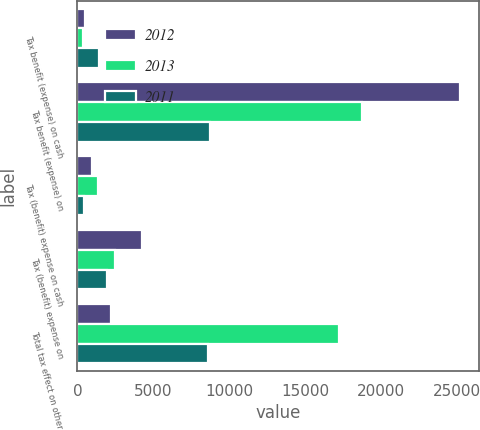<chart> <loc_0><loc_0><loc_500><loc_500><stacked_bar_chart><ecel><fcel>Tax benefit (expense) on cash<fcel>Tax benefit (expense) on<fcel>Tax (benefit) expense on cash<fcel>Tax (benefit) expense on<fcel>Total tax effect on other<nl><fcel>2012<fcel>511<fcel>25193<fcel>946<fcel>4275<fcel>2235.5<nl><fcel>2013<fcel>384<fcel>18714<fcel>1378<fcel>2498<fcel>17210<nl><fcel>2011<fcel>1395<fcel>8757<fcel>402<fcel>1973<fcel>8581<nl></chart> 